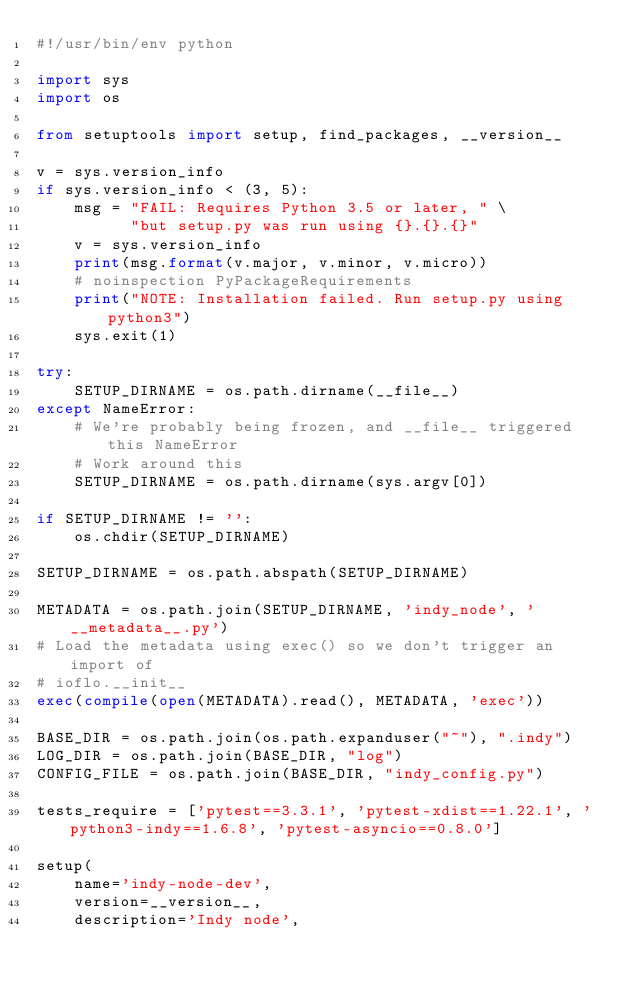<code> <loc_0><loc_0><loc_500><loc_500><_Python_>#!/usr/bin/env python

import sys
import os

from setuptools import setup, find_packages, __version__

v = sys.version_info
if sys.version_info < (3, 5):
    msg = "FAIL: Requires Python 3.5 or later, " \
          "but setup.py was run using {}.{}.{}"
    v = sys.version_info
    print(msg.format(v.major, v.minor, v.micro))
    # noinspection PyPackageRequirements
    print("NOTE: Installation failed. Run setup.py using python3")
    sys.exit(1)

try:
    SETUP_DIRNAME = os.path.dirname(__file__)
except NameError:
    # We're probably being frozen, and __file__ triggered this NameError
    # Work around this
    SETUP_DIRNAME = os.path.dirname(sys.argv[0])

if SETUP_DIRNAME != '':
    os.chdir(SETUP_DIRNAME)

SETUP_DIRNAME = os.path.abspath(SETUP_DIRNAME)

METADATA = os.path.join(SETUP_DIRNAME, 'indy_node', '__metadata__.py')
# Load the metadata using exec() so we don't trigger an import of
# ioflo.__init__
exec(compile(open(METADATA).read(), METADATA, 'exec'))

BASE_DIR = os.path.join(os.path.expanduser("~"), ".indy")
LOG_DIR = os.path.join(BASE_DIR, "log")
CONFIG_FILE = os.path.join(BASE_DIR, "indy_config.py")

tests_require = ['pytest==3.3.1', 'pytest-xdist==1.22.1', 'python3-indy==1.6.8', 'pytest-asyncio==0.8.0']

setup(
    name='indy-node-dev',
    version=__version__,
    description='Indy node',</code> 